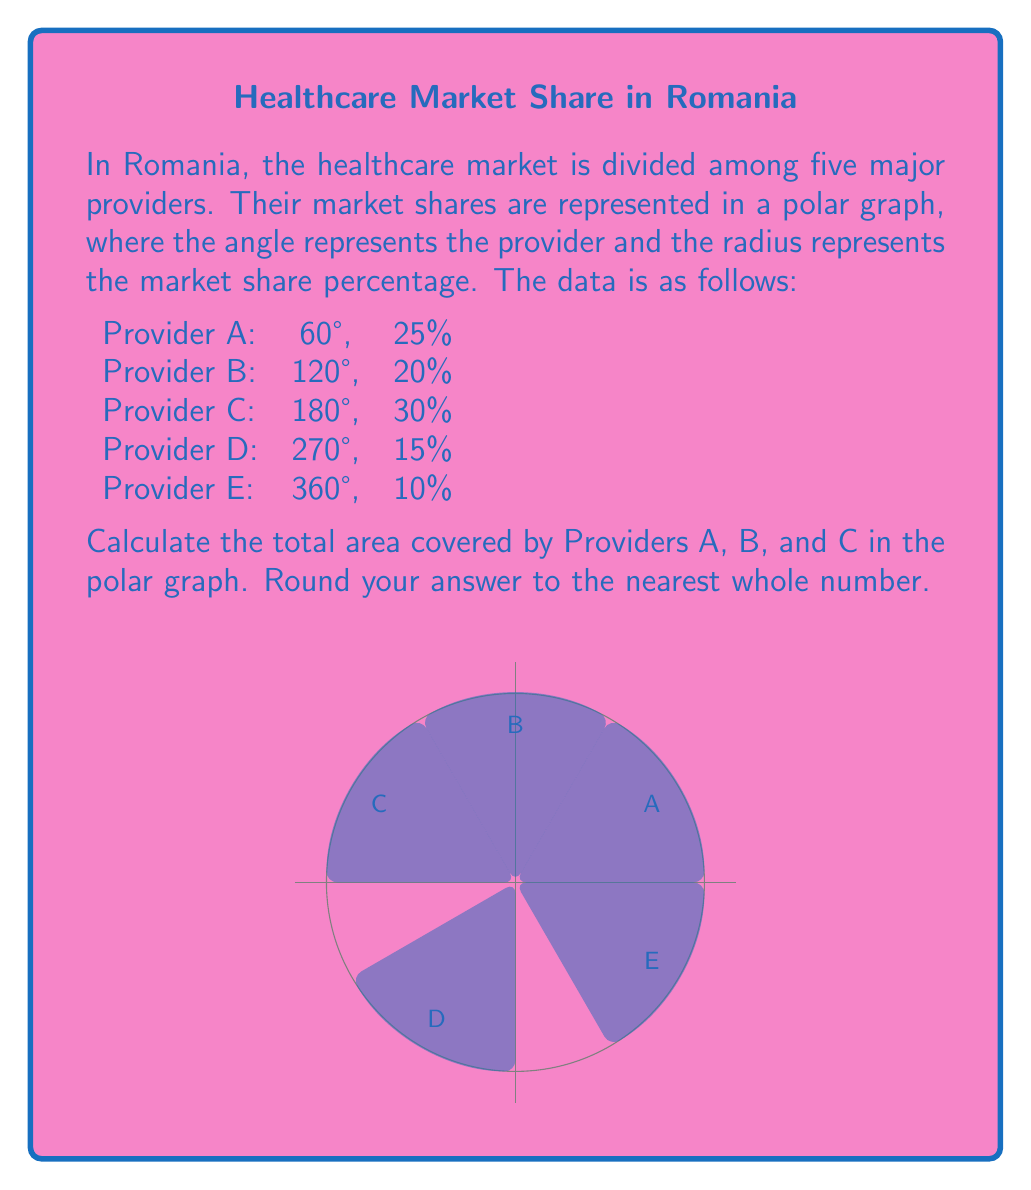Give your solution to this math problem. To calculate the area covered by Providers A, B, and C in the polar graph, we need to use the formula for the area of a sector in polar coordinates:

$$ A = \frac{1}{2} r^2 \theta $$

where $A$ is the area, $r$ is the radius (market share percentage), and $\theta$ is the angle in radians.

Step 1: Convert angles from degrees to radians
$$ \theta_A = 60° \cdot \frac{\pi}{180°} = \frac{\pi}{3} \text{ rad} $$
$$ \theta_B = 120° \cdot \frac{\pi}{180°} = \frac{2\pi}{3} \text{ rad} $$
$$ \theta_C = 180° \cdot \frac{\pi}{180°} = \pi \text{ rad} $$

Step 2: Calculate the area for each provider
Provider A: $$ A_A = \frac{1}{2} (0.25)^2 \cdot \frac{\pi}{3} = \frac{\pi}{96} $$
Provider B: $$ A_B = \frac{1}{2} (0.20)^2 \cdot \frac{2\pi}{3} = \frac{\pi}{75} $$
Provider C: $$ A_C = \frac{1}{2} (0.30)^2 \cdot \pi = \frac{9\pi}{200} $$

Step 3: Sum up the areas
$$ A_{total} = A_A + A_B + A_C = \frac{\pi}{96} + \frac{\pi}{75} + \frac{9\pi}{200} $$
$$ A_{total} = \frac{25\pi}{2400} + \frac{32\pi}{2400} + \frac{108\pi}{2400} = \frac{165\pi}{2400} $$

Step 4: Convert to a numerical value and round to the nearest whole number
$$ A_{total} = \frac{165\pi}{2400} \approx 0.2157 $$

Since the area in a polar graph doesn't have a specific unit, we can multiply by 100 to get a more meaningful number:

$$ A_{total} \cdot 100 \approx 21.57 $$

Rounding to the nearest whole number: 22
Answer: 22 